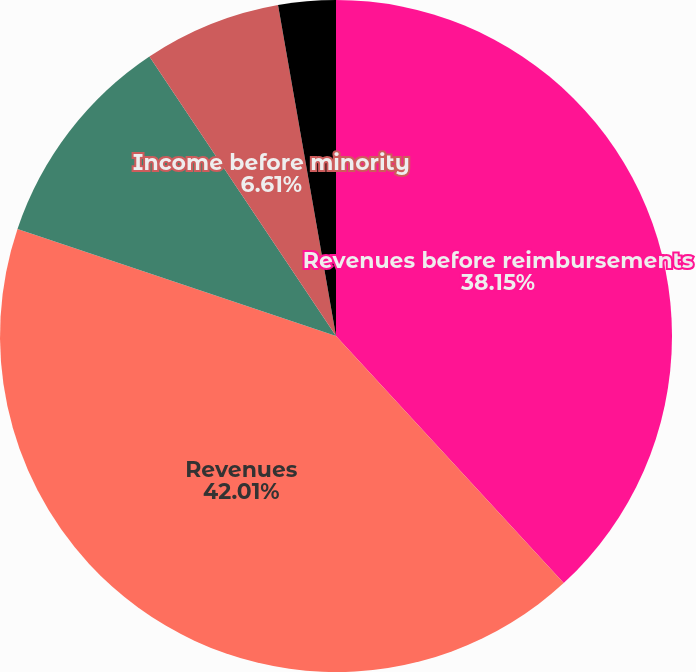Convert chart to OTSL. <chart><loc_0><loc_0><loc_500><loc_500><pie_chart><fcel>Revenues before reimbursements<fcel>Revenues<fcel>Operating income<fcel>Income before minority<fcel>Net income<nl><fcel>38.15%<fcel>42.01%<fcel>10.47%<fcel>6.61%<fcel>2.76%<nl></chart> 